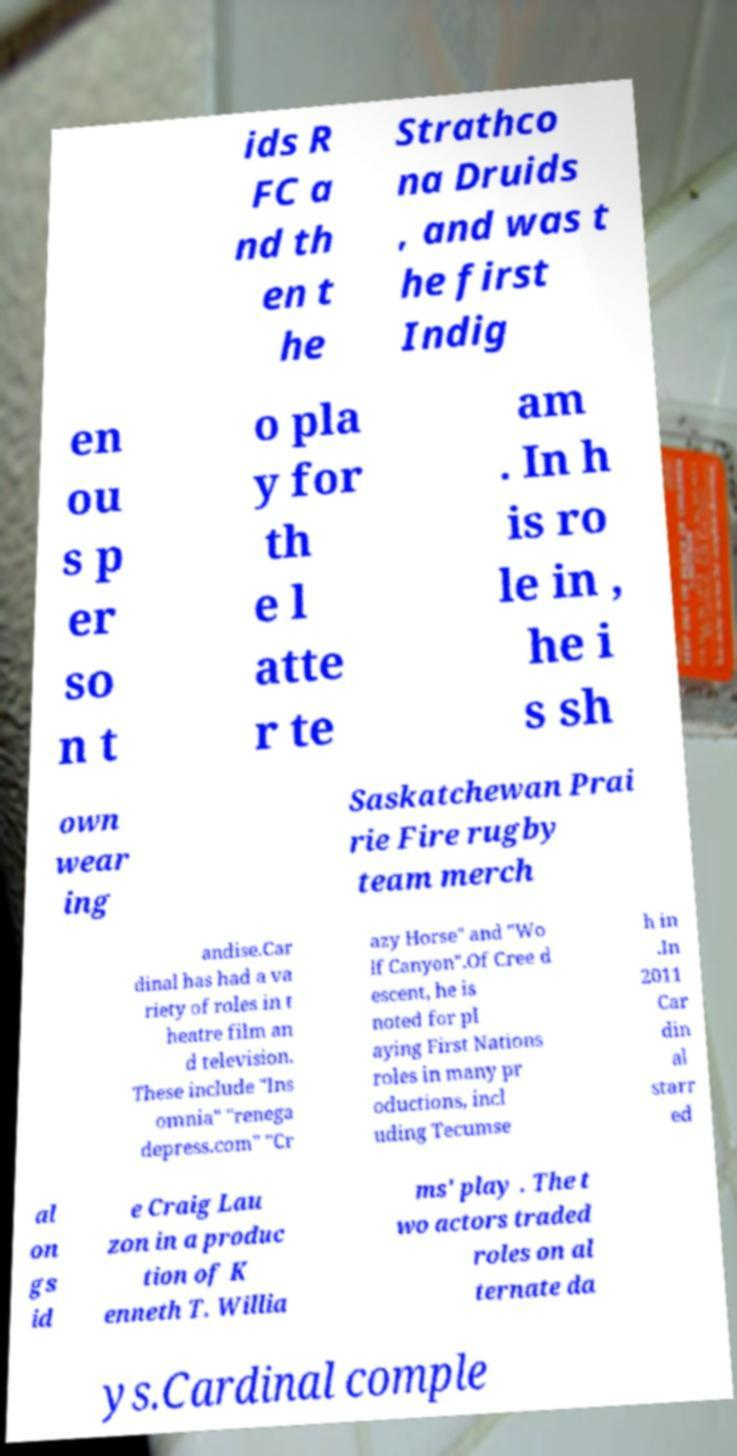There's text embedded in this image that I need extracted. Can you transcribe it verbatim? ids R FC a nd th en t he Strathco na Druids , and was t he first Indig en ou s p er so n t o pla y for th e l atte r te am . In h is ro le in , he i s sh own wear ing Saskatchewan Prai rie Fire rugby team merch andise.Car dinal has had a va riety of roles in t heatre film an d television. These include "Ins omnia" "renega depress.com" "Cr azy Horse" and "Wo lf Canyon".Of Cree d escent, he is noted for pl aying First Nations roles in many pr oductions, incl uding Tecumse h in .In 2011 Car din al starr ed al on gs id e Craig Lau zon in a produc tion of K enneth T. Willia ms' play . The t wo actors traded roles on al ternate da ys.Cardinal comple 